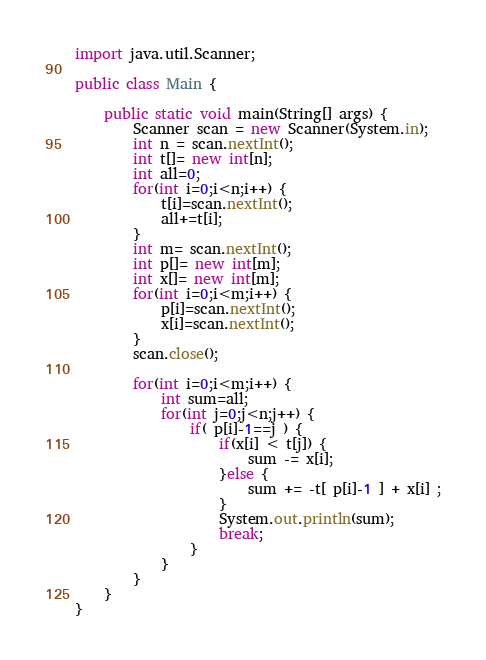Convert code to text. <code><loc_0><loc_0><loc_500><loc_500><_Java_>import java.util.Scanner;

public class Main {

	public static void main(String[] args) {
		Scanner scan = new Scanner(System.in);
		int n = scan.nextInt();
		int t[]= new int[n];
		int all=0;
		for(int i=0;i<n;i++) {
			t[i]=scan.nextInt();
			all+=t[i];
		}
		int m= scan.nextInt();
		int p[]= new int[m];
		int x[]= new int[m];
		for(int i=0;i<m;i++) {
			p[i]=scan.nextInt();
			x[i]=scan.nextInt();
		}
		scan.close();

		for(int i=0;i<m;i++) {
			int sum=all;
			for(int j=0;j<n;j++) {
				if( p[i]-1==j ) {
					if(x[i] < t[j]) {
						sum -= x[i];
					}else {
						sum += -t[ p[i]-1 ] + x[i] ;
					}
					System.out.println(sum);
					break;
				}
			}
		}
	}
}</code> 